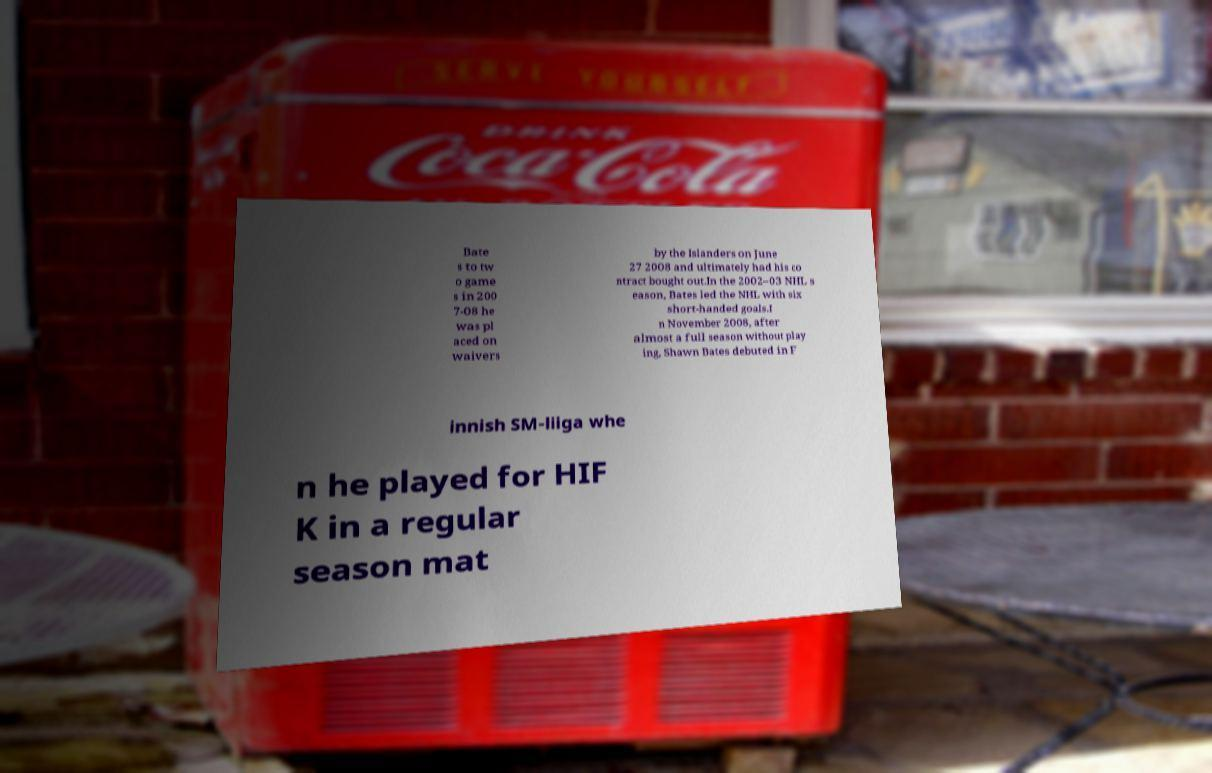Could you extract and type out the text from this image? Bate s to tw o game s in 200 7-08 he was pl aced on waivers by the Islanders on June 27 2008 and ultimately had his co ntract bought out.In the 2002–03 NHL s eason, Bates led the NHL with six short-handed goals.I n November 2008, after almost a full season without play ing, Shawn Bates debuted in F innish SM-liiga whe n he played for HIF K in a regular season mat 